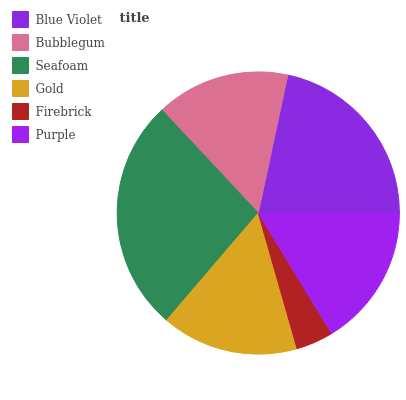Is Firebrick the minimum?
Answer yes or no. Yes. Is Seafoam the maximum?
Answer yes or no. Yes. Is Bubblegum the minimum?
Answer yes or no. No. Is Bubblegum the maximum?
Answer yes or no. No. Is Blue Violet greater than Bubblegum?
Answer yes or no. Yes. Is Bubblegum less than Blue Violet?
Answer yes or no. Yes. Is Bubblegum greater than Blue Violet?
Answer yes or no. No. Is Blue Violet less than Bubblegum?
Answer yes or no. No. Is Purple the high median?
Answer yes or no. Yes. Is Gold the low median?
Answer yes or no. Yes. Is Seafoam the high median?
Answer yes or no. No. Is Seafoam the low median?
Answer yes or no. No. 